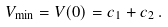Convert formula to latex. <formula><loc_0><loc_0><loc_500><loc_500>V _ { \min } = V ( 0 ) = c _ { 1 } + c _ { 2 } \, .</formula> 